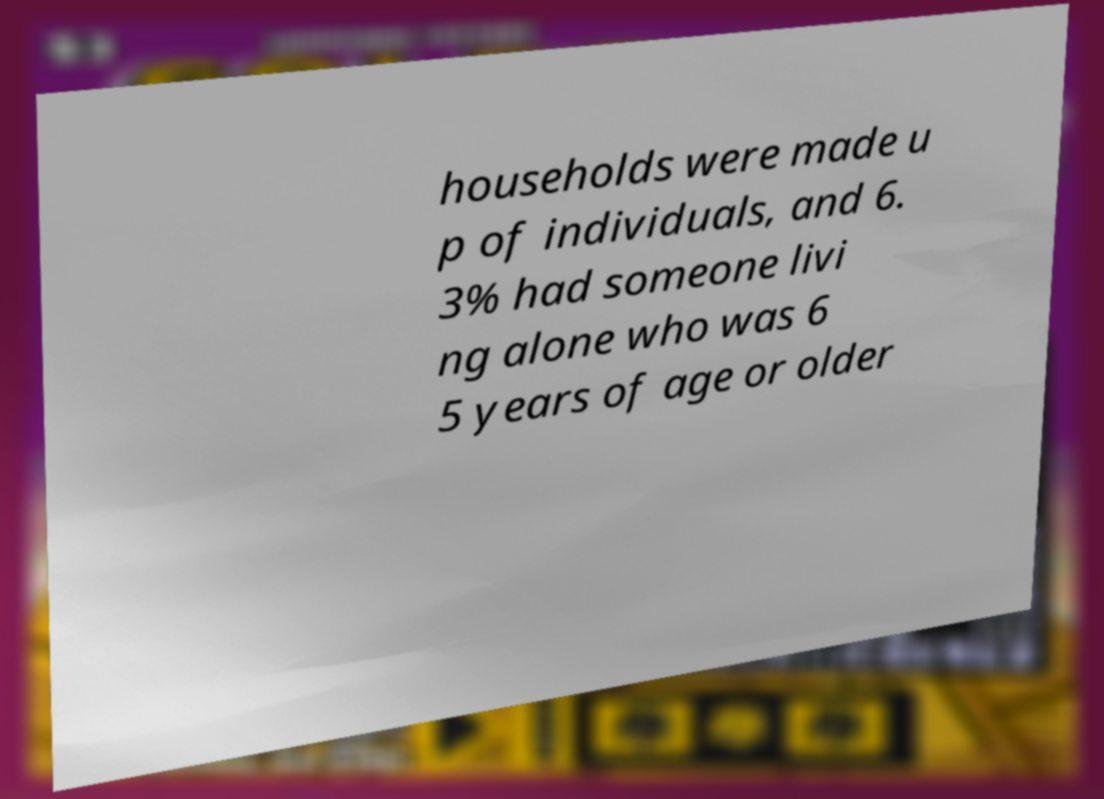Please identify and transcribe the text found in this image. households were made u p of individuals, and 6. 3% had someone livi ng alone who was 6 5 years of age or older 